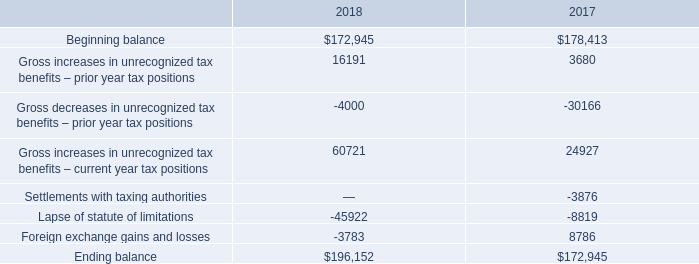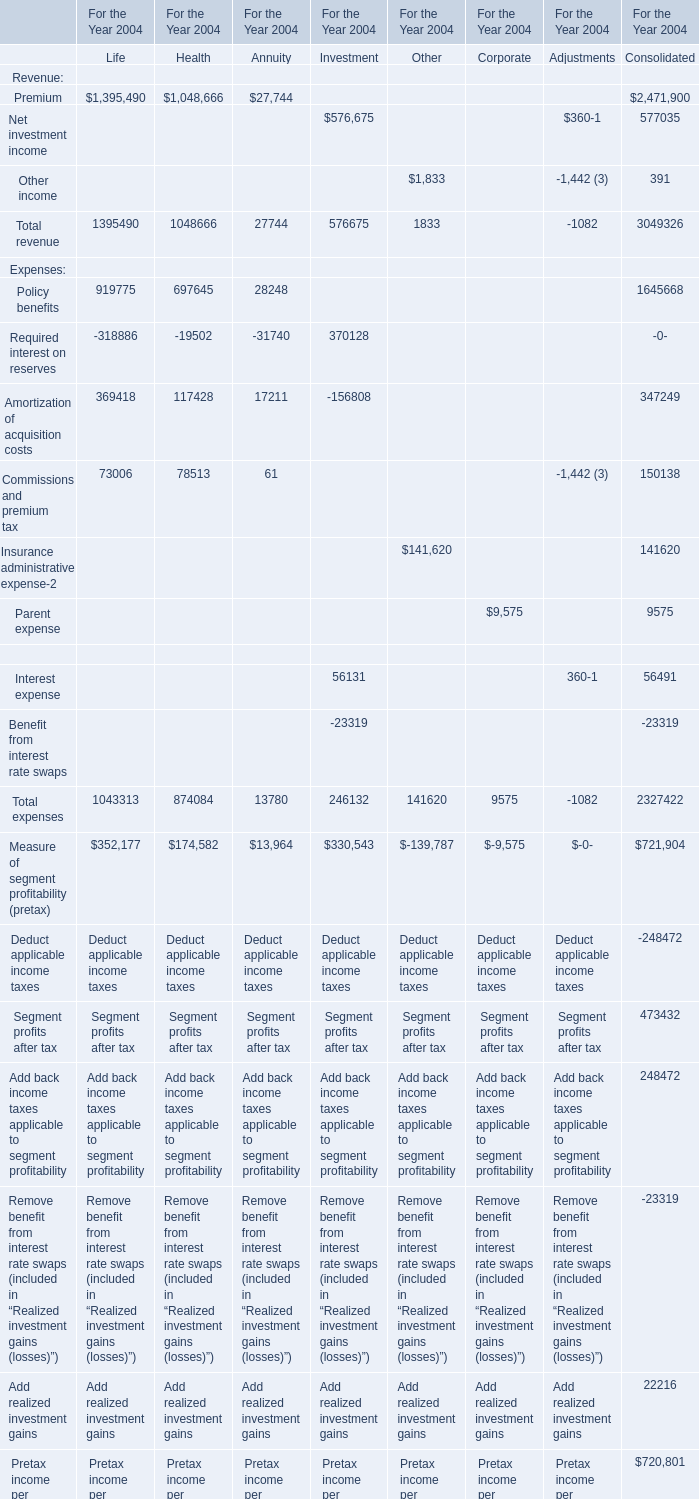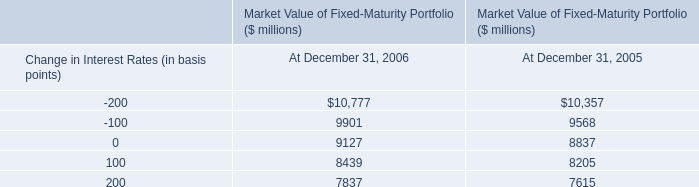In terms of Consolidated,what was the sum of the Total revenue without the Revenue that is smaller than 1000, in 2004? 
Computations: (2471900 + 577035)
Answer: 3048935.0. 